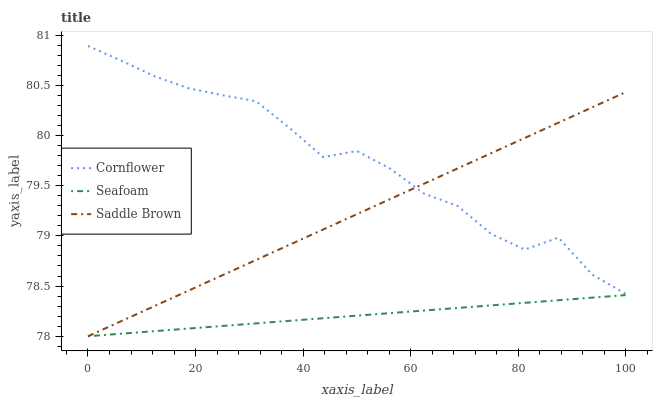Does Seafoam have the minimum area under the curve?
Answer yes or no. Yes. Does Cornflower have the maximum area under the curve?
Answer yes or no. Yes. Does Saddle Brown have the minimum area under the curve?
Answer yes or no. No. Does Saddle Brown have the maximum area under the curve?
Answer yes or no. No. Is Seafoam the smoothest?
Answer yes or no. Yes. Is Cornflower the roughest?
Answer yes or no. Yes. Is Saddle Brown the smoothest?
Answer yes or no. No. Is Saddle Brown the roughest?
Answer yes or no. No. Does Cornflower have the highest value?
Answer yes or no. Yes. Does Saddle Brown have the highest value?
Answer yes or no. No. Is Seafoam less than Cornflower?
Answer yes or no. Yes. Is Cornflower greater than Seafoam?
Answer yes or no. Yes. Does Saddle Brown intersect Seafoam?
Answer yes or no. Yes. Is Saddle Brown less than Seafoam?
Answer yes or no. No. Is Saddle Brown greater than Seafoam?
Answer yes or no. No. Does Seafoam intersect Cornflower?
Answer yes or no. No. 